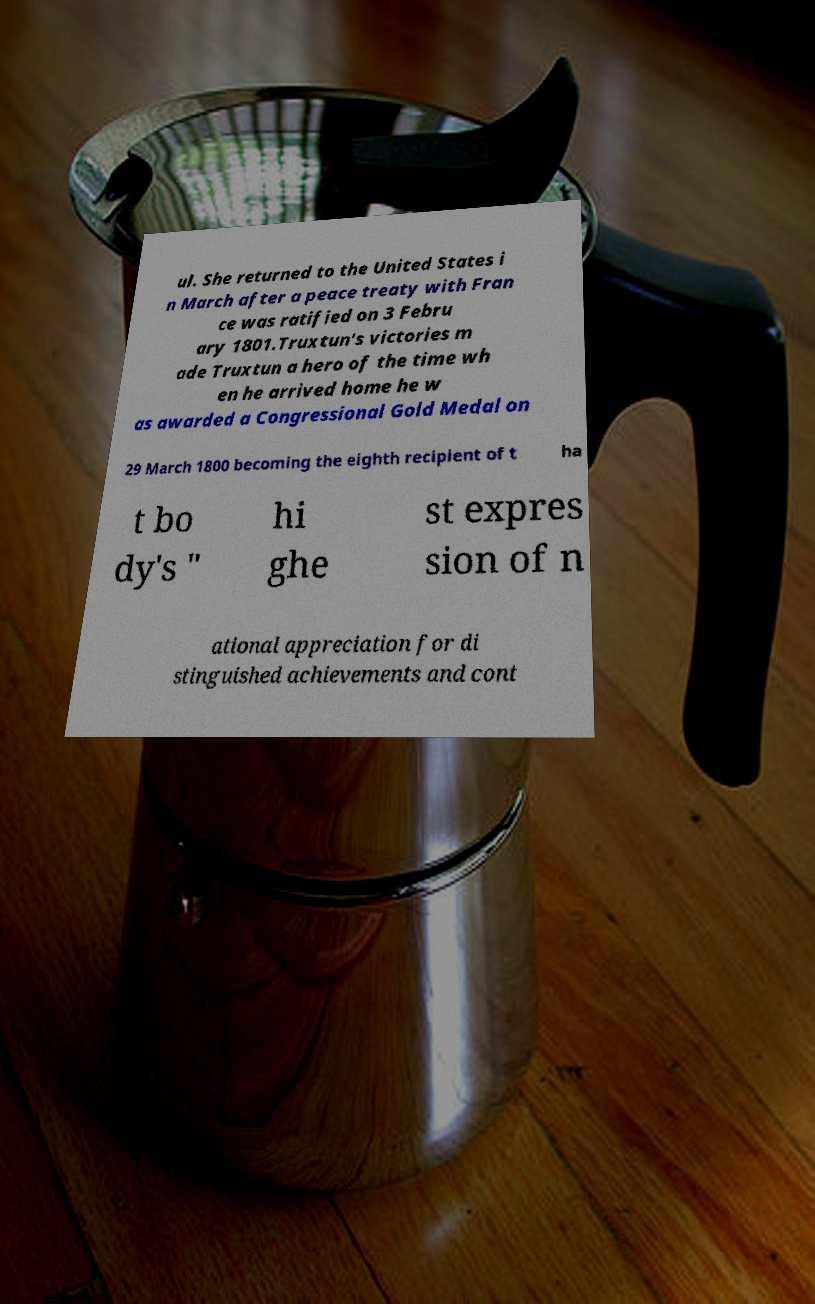Can you accurately transcribe the text from the provided image for me? ul. She returned to the United States i n March after a peace treaty with Fran ce was ratified on 3 Febru ary 1801.Truxtun's victories m ade Truxtun a hero of the time wh en he arrived home he w as awarded a Congressional Gold Medal on 29 March 1800 becoming the eighth recipient of t ha t bo dy's " hi ghe st expres sion of n ational appreciation for di stinguished achievements and cont 